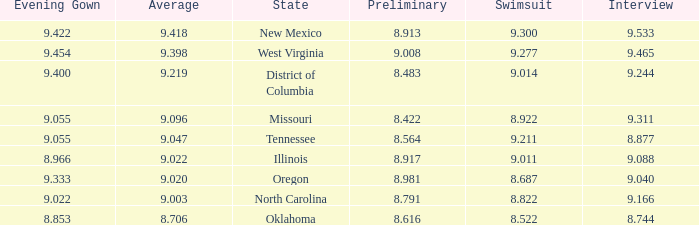Name the preliminary for north carolina 8.791. 